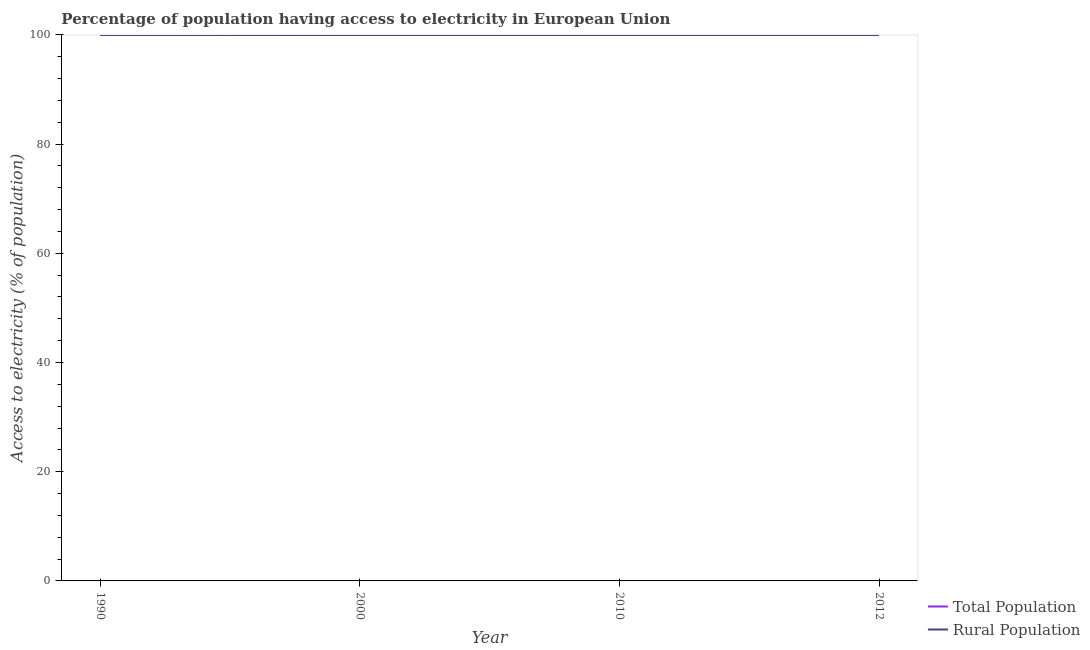How many different coloured lines are there?
Your response must be concise. 2. Does the line corresponding to percentage of population having access to electricity intersect with the line corresponding to percentage of rural population having access to electricity?
Provide a short and direct response. Yes. Across all years, what is the minimum percentage of rural population having access to electricity?
Give a very brief answer. 99.99. What is the total percentage of population having access to electricity in the graph?
Offer a very short reply. 399.99. What is the difference between the percentage of rural population having access to electricity in 1990 and that in 2000?
Keep it short and to the point. -0.01. What is the average percentage of rural population having access to electricity per year?
Keep it short and to the point. 100. In the year 2010, what is the difference between the percentage of population having access to electricity and percentage of rural population having access to electricity?
Your answer should be very brief. 0. In how many years, is the percentage of population having access to electricity greater than 84 %?
Keep it short and to the point. 4. Is the percentage of rural population having access to electricity in 2010 less than that in 2012?
Give a very brief answer. No. Is the difference between the percentage of population having access to electricity in 1990 and 2010 greater than the difference between the percentage of rural population having access to electricity in 1990 and 2010?
Your answer should be compact. Yes. What is the difference between the highest and the second highest percentage of rural population having access to electricity?
Your answer should be very brief. 0. What is the difference between the highest and the lowest percentage of population having access to electricity?
Offer a terse response. 0.01. Is the sum of the percentage of rural population having access to electricity in 2000 and 2010 greater than the maximum percentage of population having access to electricity across all years?
Keep it short and to the point. Yes. Is the percentage of population having access to electricity strictly greater than the percentage of rural population having access to electricity over the years?
Make the answer very short. No. Is the percentage of population having access to electricity strictly less than the percentage of rural population having access to electricity over the years?
Keep it short and to the point. No. How many lines are there?
Give a very brief answer. 2. Are the values on the major ticks of Y-axis written in scientific E-notation?
Provide a short and direct response. No. What is the title of the graph?
Provide a succinct answer. Percentage of population having access to electricity in European Union. Does "Mineral" appear as one of the legend labels in the graph?
Your answer should be very brief. No. What is the label or title of the X-axis?
Keep it short and to the point. Year. What is the label or title of the Y-axis?
Ensure brevity in your answer.  Access to electricity (% of population). What is the Access to electricity (% of population) in Total Population in 1990?
Provide a succinct answer. 99.99. What is the Access to electricity (% of population) in Rural Population in 1990?
Ensure brevity in your answer.  99.99. What is the Access to electricity (% of population) in Total Population in 2000?
Your answer should be compact. 100. What is the Access to electricity (% of population) in Rural Population in 2010?
Make the answer very short. 100. What is the Access to electricity (% of population) in Rural Population in 2012?
Keep it short and to the point. 100. Across all years, what is the maximum Access to electricity (% of population) of Total Population?
Your answer should be compact. 100. Across all years, what is the maximum Access to electricity (% of population) in Rural Population?
Provide a succinct answer. 100. Across all years, what is the minimum Access to electricity (% of population) in Total Population?
Provide a succinct answer. 99.99. Across all years, what is the minimum Access to electricity (% of population) in Rural Population?
Ensure brevity in your answer.  99.99. What is the total Access to electricity (% of population) in Total Population in the graph?
Your answer should be very brief. 399.99. What is the total Access to electricity (% of population) in Rural Population in the graph?
Offer a very short reply. 399.99. What is the difference between the Access to electricity (% of population) of Total Population in 1990 and that in 2000?
Your answer should be compact. -0.01. What is the difference between the Access to electricity (% of population) of Rural Population in 1990 and that in 2000?
Your answer should be compact. -0.01. What is the difference between the Access to electricity (% of population) in Total Population in 1990 and that in 2010?
Ensure brevity in your answer.  -0.01. What is the difference between the Access to electricity (% of population) of Rural Population in 1990 and that in 2010?
Offer a very short reply. -0.01. What is the difference between the Access to electricity (% of population) of Total Population in 1990 and that in 2012?
Make the answer very short. -0.01. What is the difference between the Access to electricity (% of population) in Rural Population in 1990 and that in 2012?
Your answer should be compact. -0.01. What is the difference between the Access to electricity (% of population) of Total Population in 2000 and that in 2012?
Provide a short and direct response. 0. What is the difference between the Access to electricity (% of population) in Rural Population in 2000 and that in 2012?
Provide a succinct answer. 0. What is the difference between the Access to electricity (% of population) of Rural Population in 2010 and that in 2012?
Your response must be concise. 0. What is the difference between the Access to electricity (% of population) in Total Population in 1990 and the Access to electricity (% of population) in Rural Population in 2000?
Keep it short and to the point. -0.01. What is the difference between the Access to electricity (% of population) of Total Population in 1990 and the Access to electricity (% of population) of Rural Population in 2010?
Your answer should be compact. -0.01. What is the difference between the Access to electricity (% of population) in Total Population in 1990 and the Access to electricity (% of population) in Rural Population in 2012?
Ensure brevity in your answer.  -0.01. What is the difference between the Access to electricity (% of population) in Total Population in 2000 and the Access to electricity (% of population) in Rural Population in 2012?
Give a very brief answer. 0. What is the difference between the Access to electricity (% of population) of Total Population in 2010 and the Access to electricity (% of population) of Rural Population in 2012?
Your answer should be very brief. 0. What is the average Access to electricity (% of population) in Total Population per year?
Keep it short and to the point. 100. What is the average Access to electricity (% of population) in Rural Population per year?
Your response must be concise. 100. In the year 1990, what is the difference between the Access to electricity (% of population) of Total Population and Access to electricity (% of population) of Rural Population?
Give a very brief answer. 0. In the year 2010, what is the difference between the Access to electricity (% of population) of Total Population and Access to electricity (% of population) of Rural Population?
Provide a short and direct response. 0. What is the ratio of the Access to electricity (% of population) of Total Population in 1990 to that in 2010?
Offer a very short reply. 1. What is the ratio of the Access to electricity (% of population) of Rural Population in 1990 to that in 2012?
Make the answer very short. 1. What is the ratio of the Access to electricity (% of population) in Total Population in 2000 to that in 2010?
Offer a very short reply. 1. What is the ratio of the Access to electricity (% of population) of Rural Population in 2000 to that in 2012?
Ensure brevity in your answer.  1. What is the difference between the highest and the second highest Access to electricity (% of population) of Rural Population?
Keep it short and to the point. 0. What is the difference between the highest and the lowest Access to electricity (% of population) of Total Population?
Offer a very short reply. 0.01. What is the difference between the highest and the lowest Access to electricity (% of population) of Rural Population?
Provide a succinct answer. 0.01. 